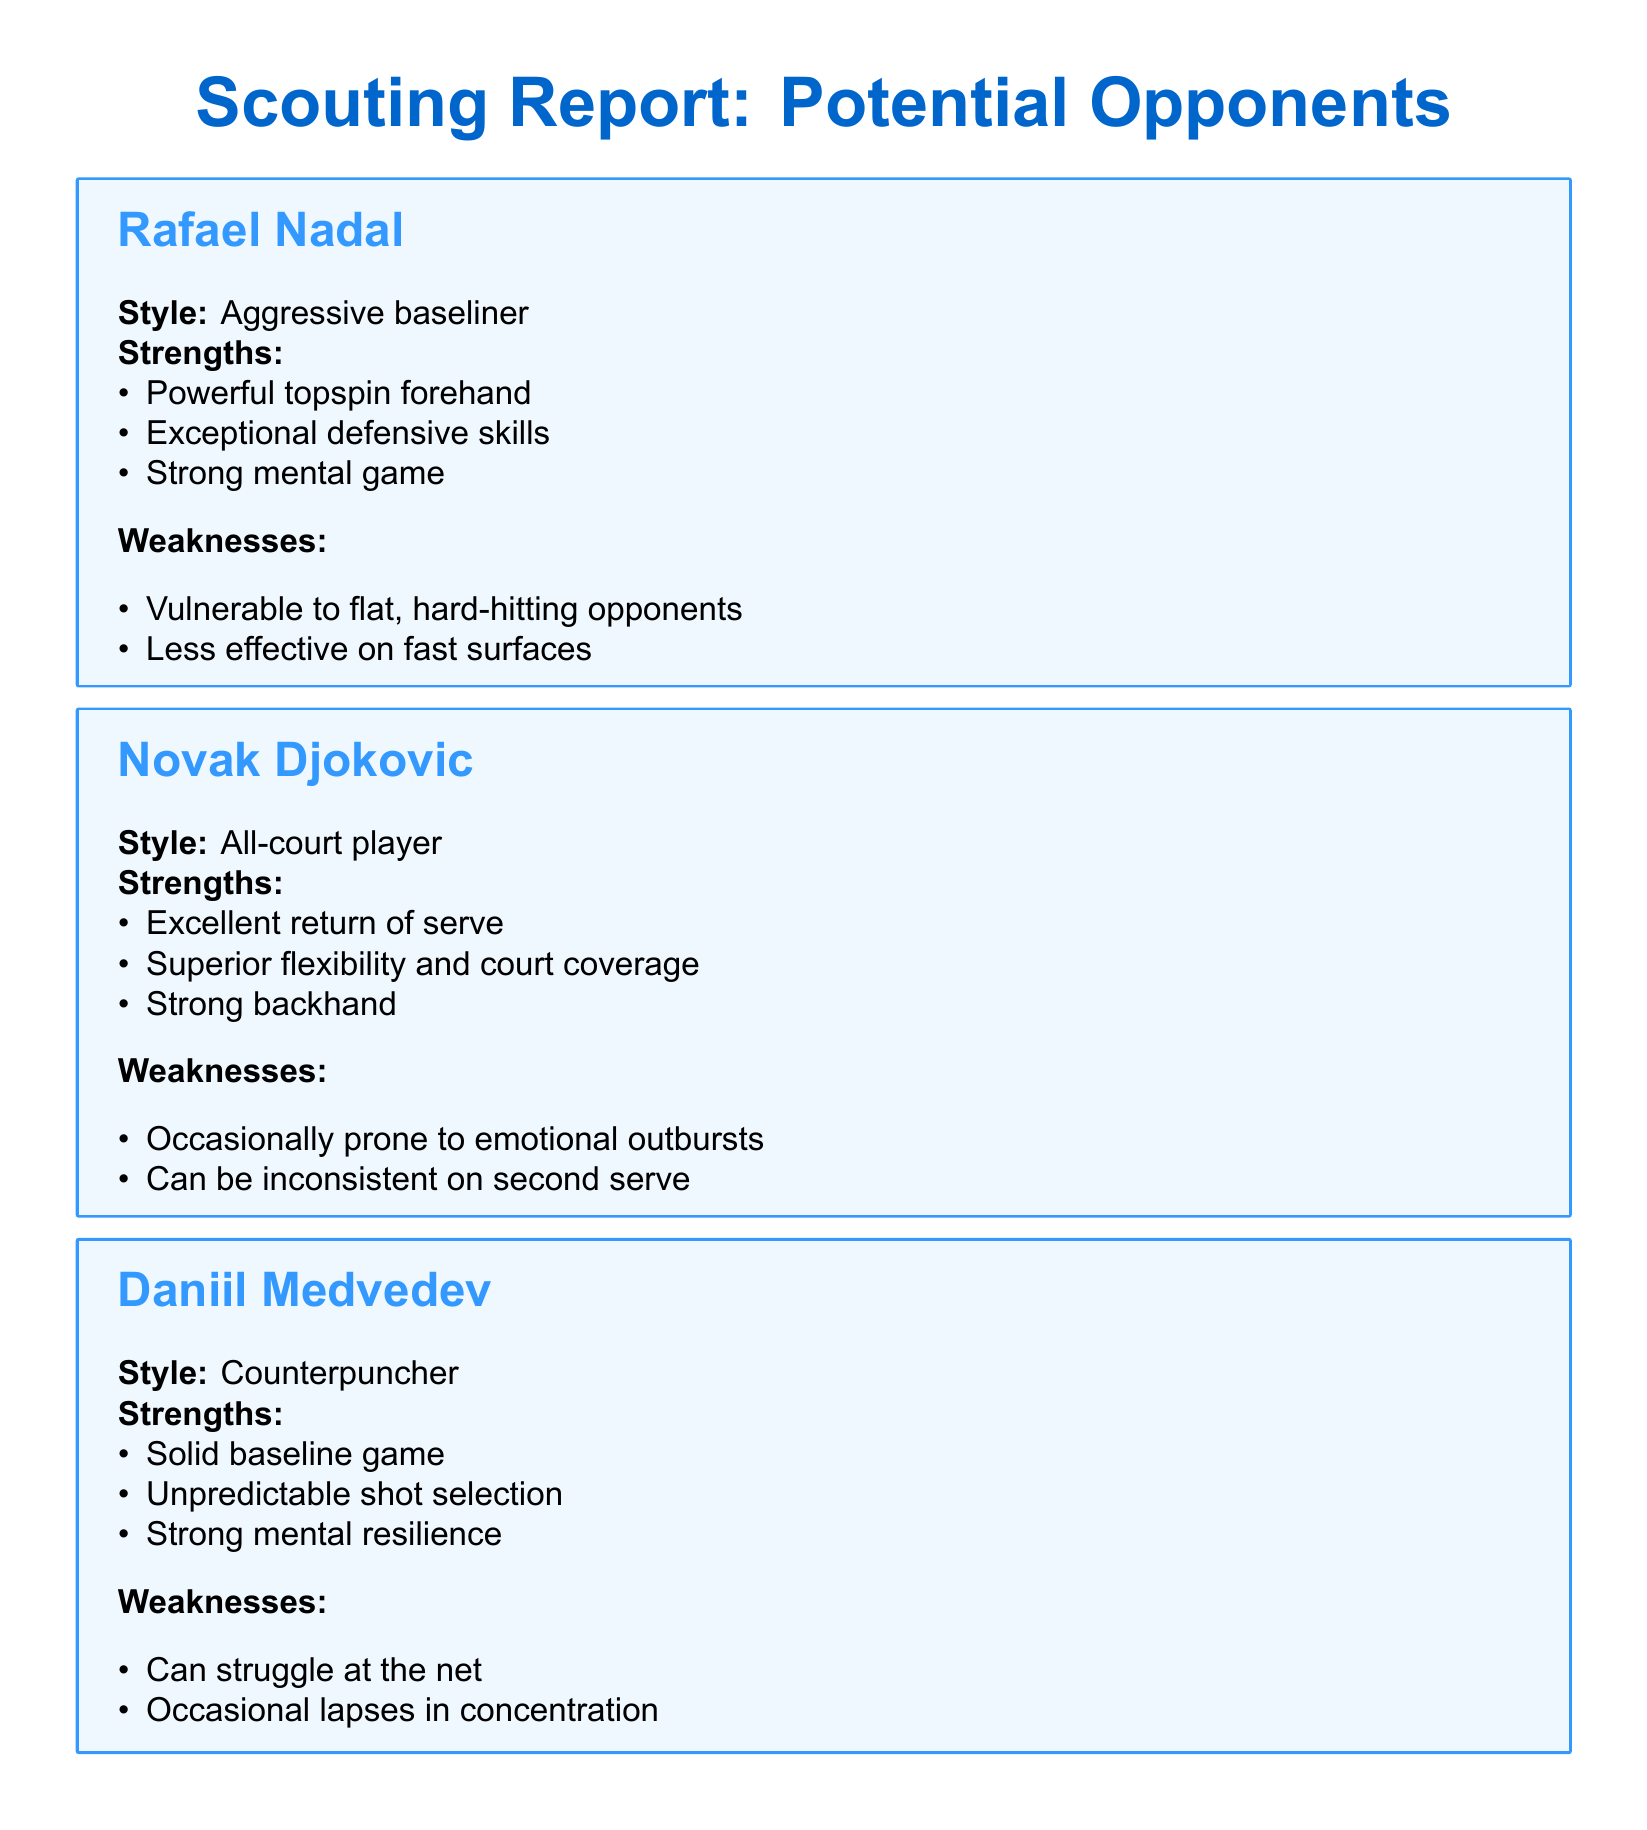What is Rafael Nadal's playing style? The playing style of Rafael Nadal is described in the scouting report as an aggressive baseliner.
Answer: Aggressive baseliner What is a key strength of Novak Djokovic? One of the strengths of Novak Djokovic is his excellent return of serve, as noted in the report.
Answer: Excellent return of serve What is a weakness of Daniil Medvedev? The scouting report lists that Daniil Medvedev can struggle at the net, which is a noted weakness.
Answer: Can struggle at the net How many weaknesses are listed for Alexander Zverev? There are two weaknesses mentioned for Alexander Zverev in the document.
Answer: Two What is one of the key factors to analyze according to the report? The report suggests analyzing recent match footage for current form as a key factor.
Answer: Analyze recent match footage for current form What is the primary style of play for Daniil Medvedev? The scouting report categorizes Daniil Medvedev as a counterpuncher.
Answer: Counterpuncher What emotional tendency is noted for Novak Djokovic? The report mentions that Novak Djokovic is occasionally prone to emotional outbursts.
Answer: Emotional outbursts Which player is noted for having a strong mental game? Rafael Nadal is highlighted in the document for having a strong mental game.
Answer: Strong mental game 